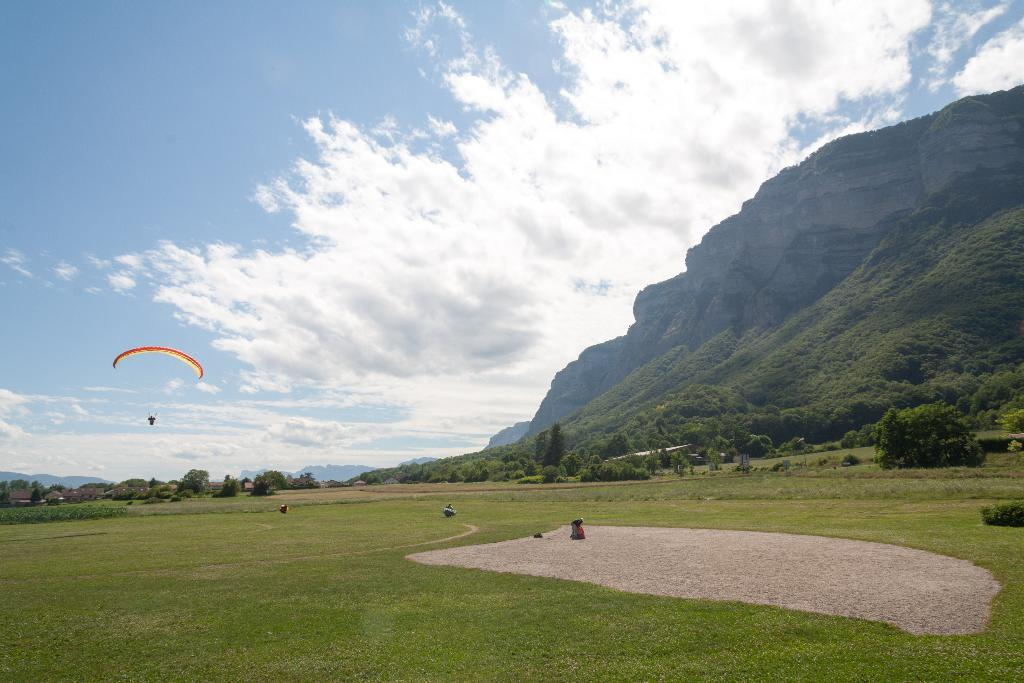What type of landscape is depicted in the image? There is a field in the image. What geographical features can be seen on the right side of the image? There are mountains on the right side of the image. What type of vegetation is visible in the background of the image? There are trees in the background of the image. What is the man in the image doing? A man with a parachute is flying in the sky. What part of the natural environment is visible in the image? The sky is visible in the image. What type of net can be seen catching the man with a parachute in the image? There is no net present in the image; the man with a parachute is flying freely in the sky. What branch is the man holding onto while parachuting in the image? There is no branch present in the image; the man is using a parachute to fly in the sky. 